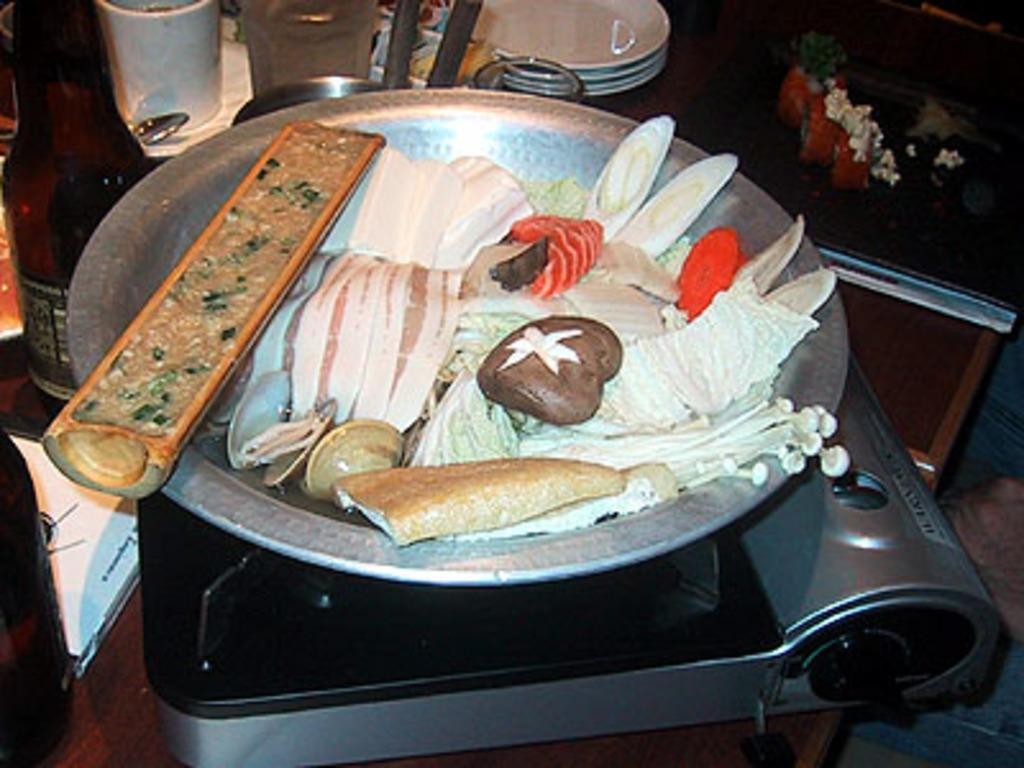What is in the bowl that is visible in the image? There is food in a bowl in the image. Where is the bowl located in the image? The bowl is on an induction stove in the image. What celestial bodies are depicted in the image? There are planets depicted in the image. What type of container is present in the image? There is a bottle in the image. What other objects can be seen in the image? There are additional objects in the image. What type of blood is visible in the image? There is no blood visible in the image. 